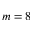Convert formula to latex. <formula><loc_0><loc_0><loc_500><loc_500>m = 8</formula> 